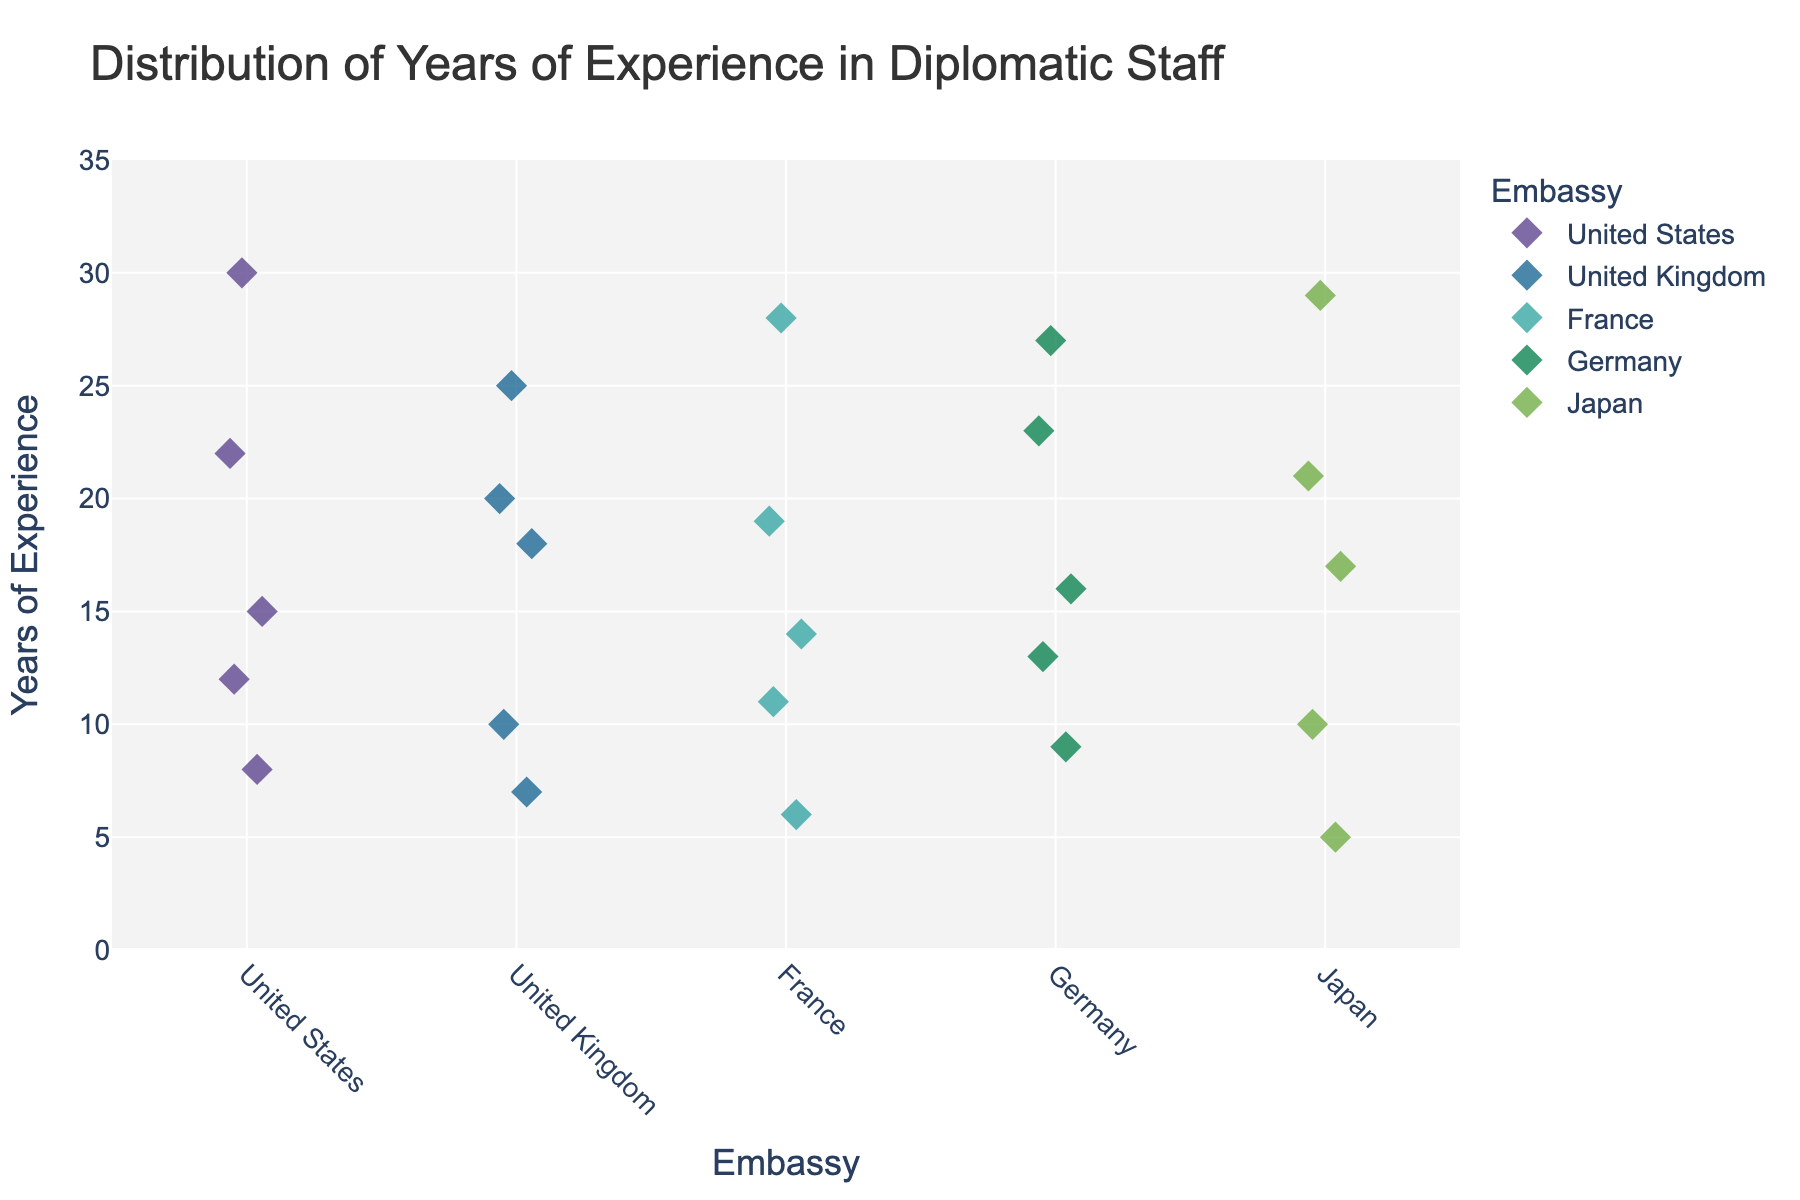What embassies are represented in the plot? The plot shows data for embassies from various countries which can be identified by looking at the x-axis labels.
Answer: United States, United Kingdom, France, Germany, Japan How many data points are there for the United Kingdom embassy? By counting the number of diamonds in the strip plot directly above the "United Kingdom" label on the x-axis.
Answer: 5 What’s the range of years of experience observed for the Japanese embassy? Identify the minimum and maximum positions of the diamond markers above "Japan" on the y-axis.
Answer: 5 to 29 Which embassy has the highest single value of years of experience? Locate the highest diamond on the y-axis and note which embassy it aligns with on the x-axis.
Answer: United States Which embassy has the widest range of experience among its staff? Look at the spread of diamonds vertically for each embassy and identify the one with the greatest distance between the highest and lowest points.
Answer: United States What is the average years of experience for the French embassy's staff? Identify all years of experience values for the French embassy, then calculate the arithmetic mean.
Answer: 15.6 Is there any embassy that has all its staff members’ years of experience under 20 years? Check each embassy to see if all the diamonds are below the 20-year mark on the y-axis.
Answer: No Which embassy has the most concentrated distribution of years of experience (smallest spread)? Find the embassy whose diamond markers occupy the smallest range on the y-axis.
Answer: United Kingdom Compare the median years of experience of the embassies of Germany and France. Which has a higher median value? Identify the middle value of the ordered list of years of experience for each embassy and compare them.
Answer: France How does the career distribution differ between the United Kingdom and Germany embassies? Compare the vertical spread and positioning of the strip plot diamonds above the "United Kingdom" and "Germany" labels on the x-axis.
Answer: United Kingdom has a smaller spread and generally lower values compared to Germany 